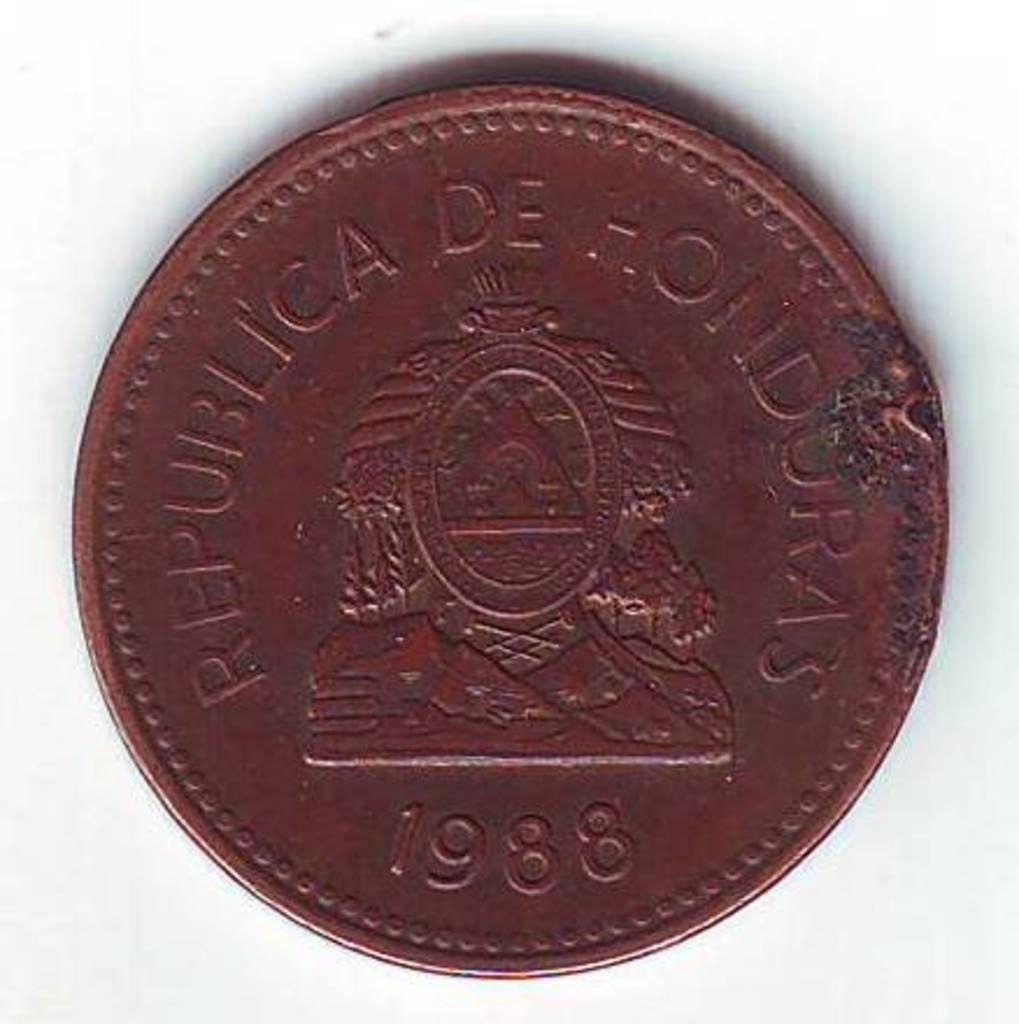<image>
Give a short and clear explanation of the subsequent image. A copper coin from the Republica de Honduras 1988 